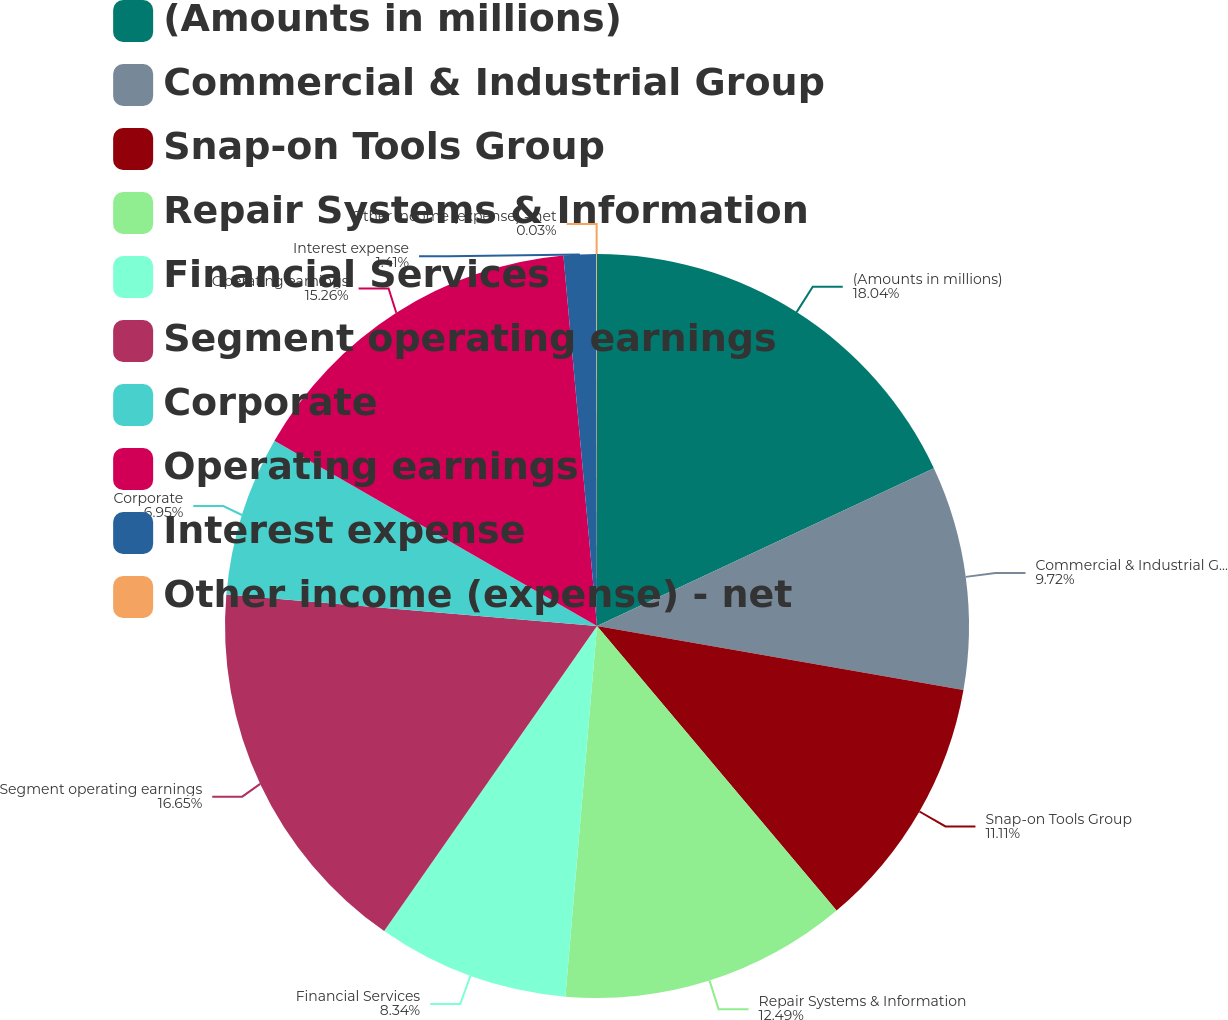<chart> <loc_0><loc_0><loc_500><loc_500><pie_chart><fcel>(Amounts in millions)<fcel>Commercial & Industrial Group<fcel>Snap-on Tools Group<fcel>Repair Systems & Information<fcel>Financial Services<fcel>Segment operating earnings<fcel>Corporate<fcel>Operating earnings<fcel>Interest expense<fcel>Other income (expense) - net<nl><fcel>18.03%<fcel>9.72%<fcel>11.11%<fcel>12.49%<fcel>8.34%<fcel>16.65%<fcel>6.95%<fcel>15.26%<fcel>1.41%<fcel>0.03%<nl></chart> 